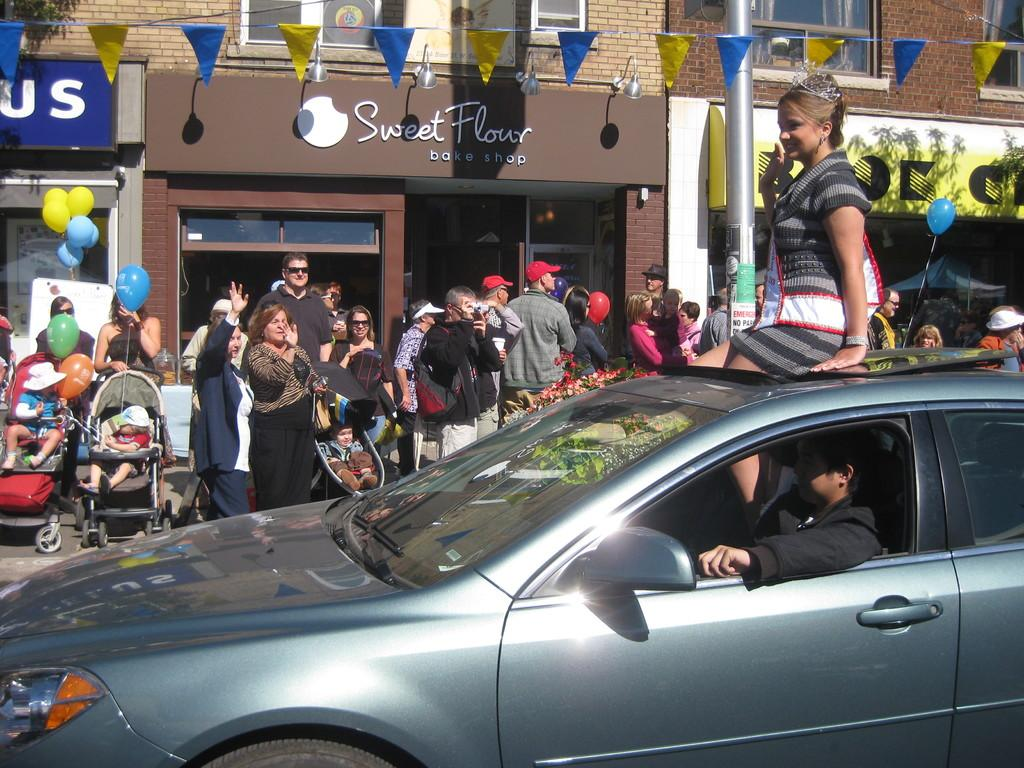What type of structure is visible in the image? There is a building in the image. Are there any living beings present in the image? Yes, there are people in the image. What mode of transportation can be seen in the image? There is a car in the image. What type of wine is being served at the gathering of friends in the image? There is no gathering of friends or wine present in the image. What type of land can be seen in the image? The image does not show any land; it only features a building, people, and a car. 